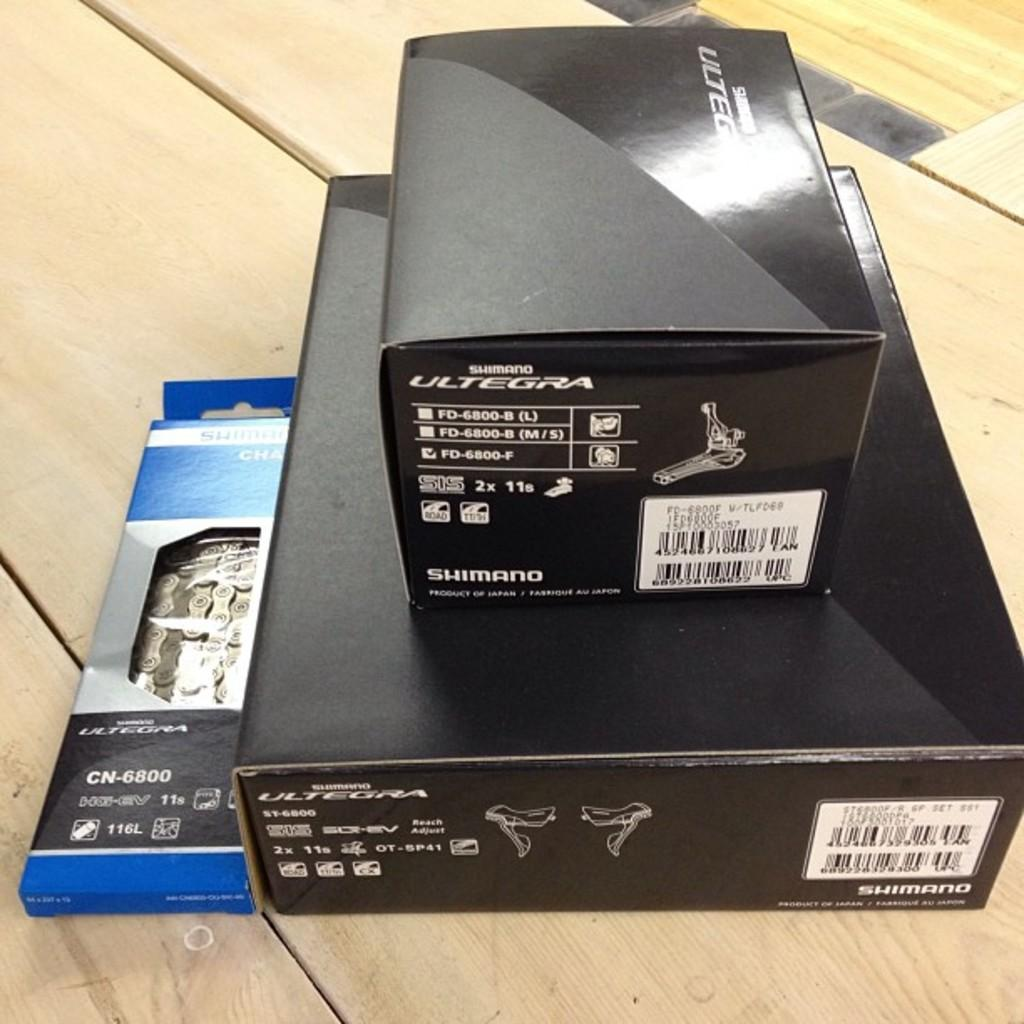What objects are present in the image? There are boxes in the image. Where are the boxes located? The boxes are placed on a wooden surface. What type of tree is present in the image? There is no tree present in the image; it only features boxes placed on a wooden surface. 